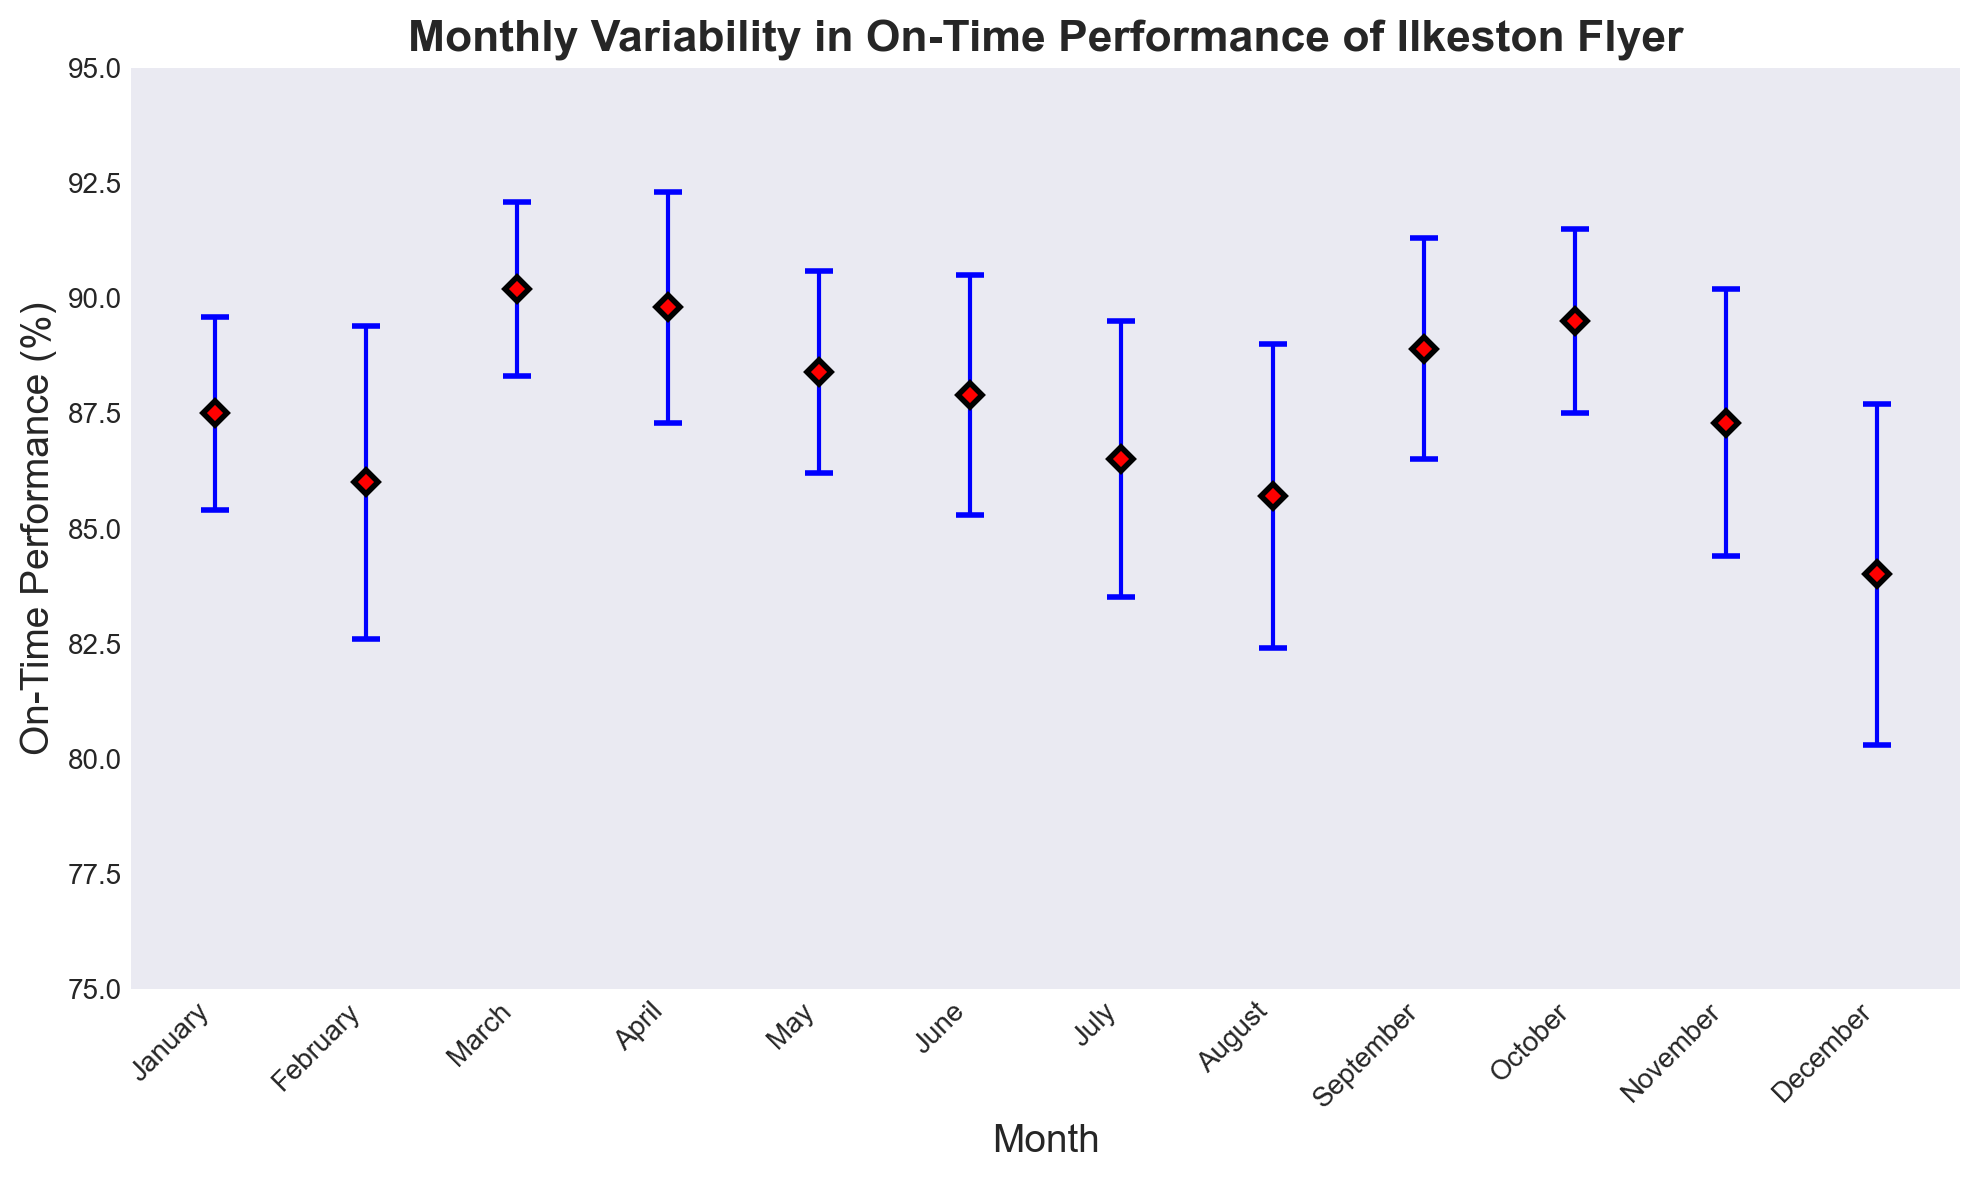Which month had the highest on-time performance? By observing the heights of the error bars, March stands out as having the highest mean on-time performance percentage at 90.2%. None of the other months surpass this value.
Answer: March Which month had the lowest on-time performance? By comparing the on-time performance percentages indicated by the data points, December has the lowest mean on-time performance percentage at 84.0%.
Answer: December What is the range of the mean on-time performance percentages displayed in the chart? The range is calculated by subtracting the lowest value from the highest value. The highest mean on-time percentage is in March at 90.2%, and the lowest is in December at 84.0%. Thus, the range is 90.2 - 84.0 = 6.2%.
Answer: 6.2% Which month shows the greatest variability in on-time performance? The greatest variability is indicated by the longest error bar. December has the highest standard deviation of 3.7%, which makes it the month with the greatest variability in on-time performance.
Answer: December Comparing September and October, which month has better on-time performance and by how much? To determine which month had better performance and the difference, we compare the mean on-time percentages: September has 88.9% and October has 89.5%. The difference is 89.5 - 88.9 = 0.6%. October is better by 0.6%.
Answer: October by 0.6% What is the average of the mean on-time performance percentages for the first quarter of the year (January, February, March)? To find the average, sum the mean percentages of January, February, and March, and then divide by 3. The average is (87.5 + 86.0 + 90.2) / 3 = 87.9%.
Answer: 87.9% How does July's on-time performance compare to the annual average? First, calculate the annual average by summing the mean percentages for all months and dividing by 12: (87.5 + 86.0 + 90.2 + 89.8 + 88.4 + 87.9 + 86.5 + 85.7 + 88.9 + 89.5 + 87.3 + 84.0) / 12 = 87.6%. July's mean on-time performance is 86.5%, which is 87.6 - 86.5 = 1.1% lower than the annual average.
Answer: 1.1% lower What is the combined range of the mean on-time performance considering the potential error for August? To find the combined range, add and subtract the standard deviation from the mean August percentage to get the potential minimum and maximum. August has a mean of 85.7% and a standard deviation of 3.3%, thus the range is from (85.7 - 3.3)% to (85.7 + 3.3)%, which is 82.4% to 89.0%. Hence, the combined range is 89.0 - 82.4 = 6.6%.
Answer: 6.6% 